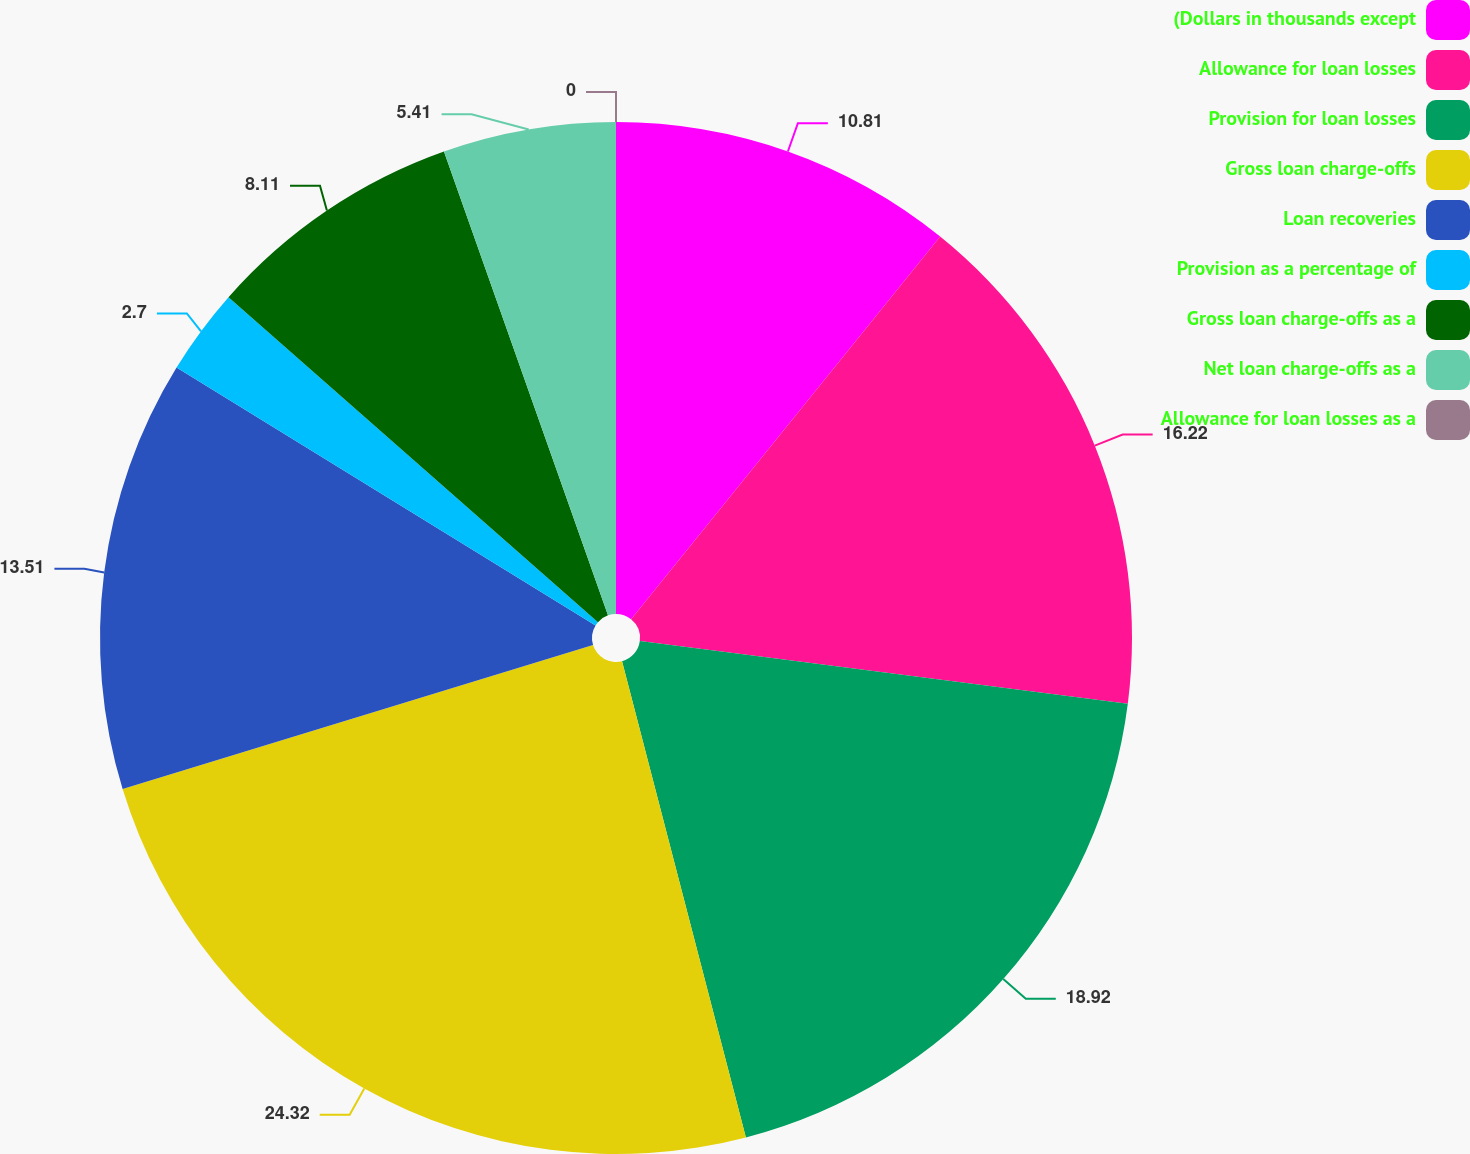<chart> <loc_0><loc_0><loc_500><loc_500><pie_chart><fcel>(Dollars in thousands except<fcel>Allowance for loan losses<fcel>Provision for loan losses<fcel>Gross loan charge-offs<fcel>Loan recoveries<fcel>Provision as a percentage of<fcel>Gross loan charge-offs as a<fcel>Net loan charge-offs as a<fcel>Allowance for loan losses as a<nl><fcel>10.81%<fcel>16.22%<fcel>18.92%<fcel>24.32%<fcel>13.51%<fcel>2.7%<fcel>8.11%<fcel>5.41%<fcel>0.0%<nl></chart> 